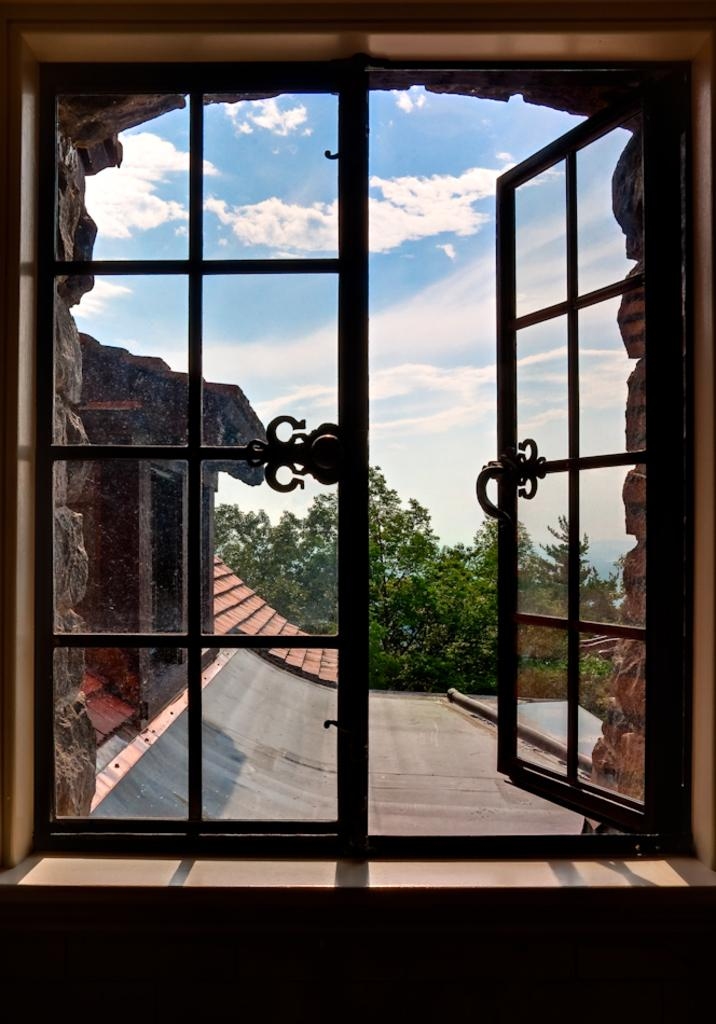What structure can be seen in the image? There is a wall in the image. What feature is present in the wall? There is a window in the image. What can be seen in the background of the image? There is a building and trees in the background of the image. What part of the natural environment is visible in the image? The sky is visible in the background of the image. What type of leather can be seen on the wall in the image? There is no leather present on the wall in the image. What is the taste of the sky visible in the background of the image? The sky does not have a taste, as it is a natural phenomenon and not a consumable item. 